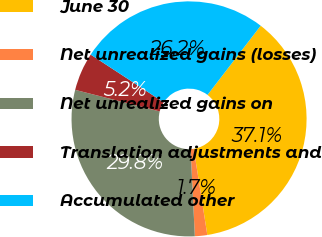Convert chart. <chart><loc_0><loc_0><loc_500><loc_500><pie_chart><fcel>June 30<fcel>Net unrealized gains (losses)<fcel>Net unrealized gains on<fcel>Translation adjustments and<fcel>Accumulated other<nl><fcel>37.09%<fcel>1.7%<fcel>29.76%<fcel>5.24%<fcel>26.22%<nl></chart> 